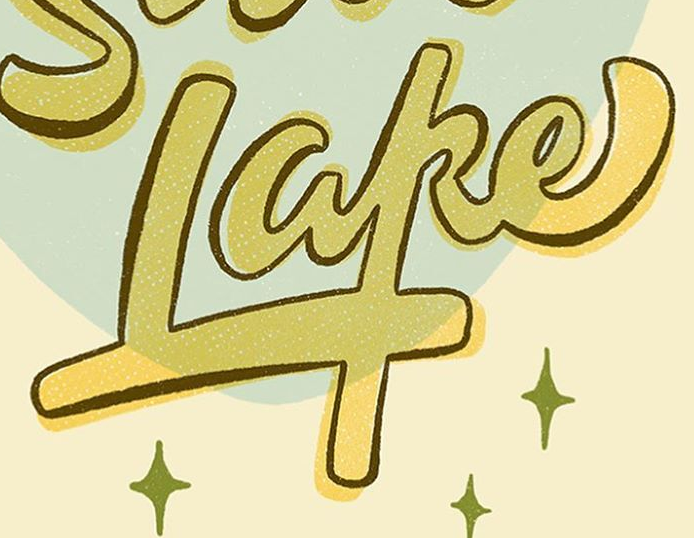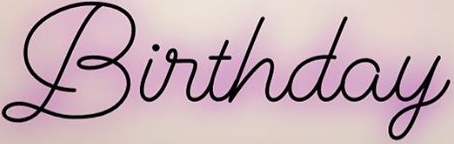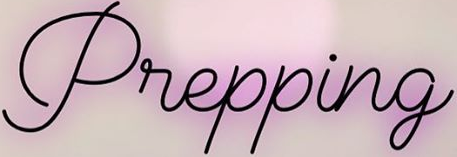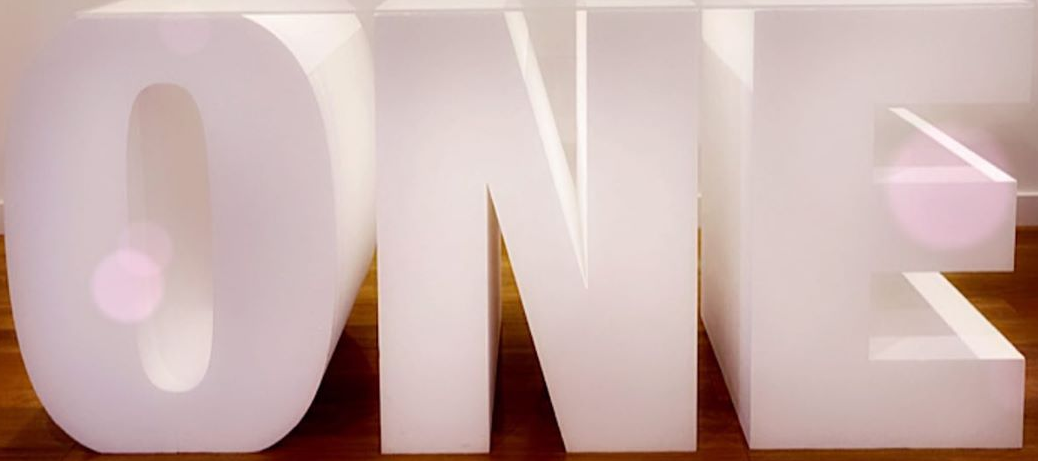What words can you see in these images in sequence, separated by a semicolon? Lake; Birthday; Prepping; ONE 